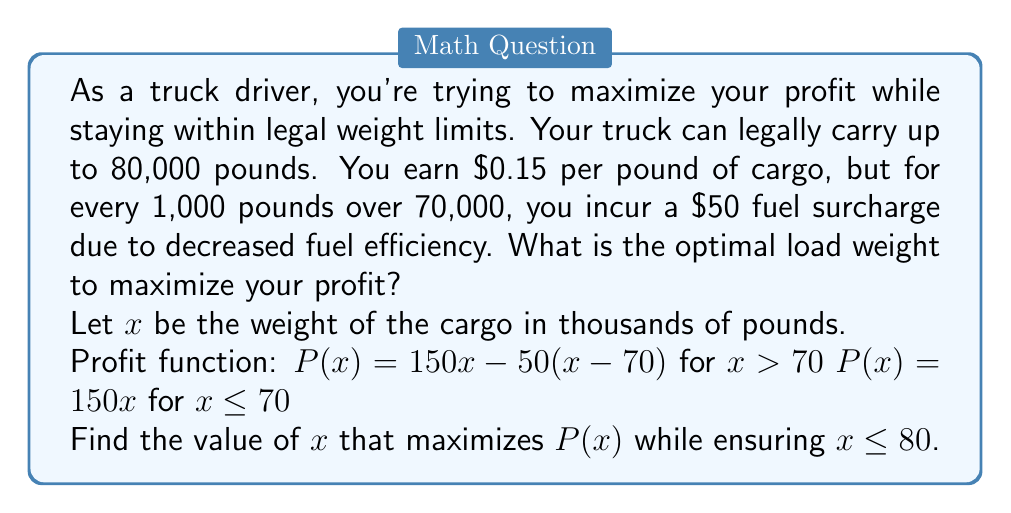Solve this math problem. Let's approach this step-by-step:

1) First, we need to consider the two parts of our profit function:

   For $x \leq 70$: $P(x) = 150x$
   For $70 < x \leq 80$: $P(x) = 150x - 50(x-70) = 150x - 50x + 3500 = 100x + 3500$

2) For $x \leq 70$, the profit increases linearly with weight. So in this range, the maximum profit would be at $x = 70$.

3) For $70 < x \leq 80$, we have a linear function $P(x) = 100x + 3500$.
   This is an increasing function, so its maximum in this range will be at the upper limit, $x = 80$.

4) Now we compare the profits at these two points:

   At $x = 70$: $P(70) = 150 * 70 = 10,500$
   At $x = 80$: $P(80) = 100 * 80 + 3500 = 11,500$

5) $11,500 > 10,500$, so the maximum profit is achieved at $x = 80$.

Therefore, the optimal load weight is 80,000 pounds, which is the maximum legal limit.
Answer: The optimal load weight to maximize profit while staying within legal limits is 80,000 pounds. 